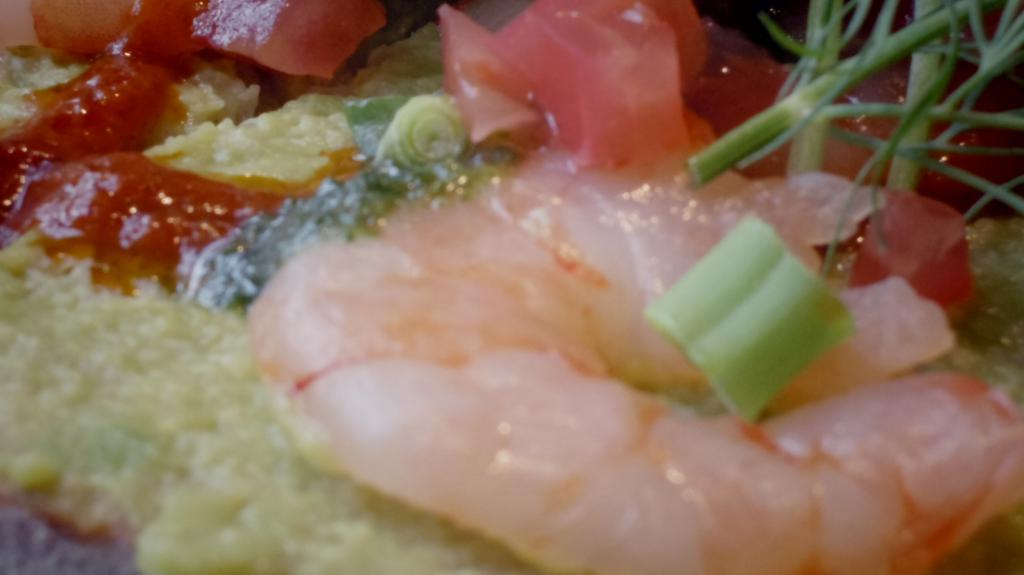What is the main subject of the image? There is a food item in the image. What type of insect can be seen crawling on the collar of the house in the image? There is no insect, collar, or house present in the image; it only features a food item. 